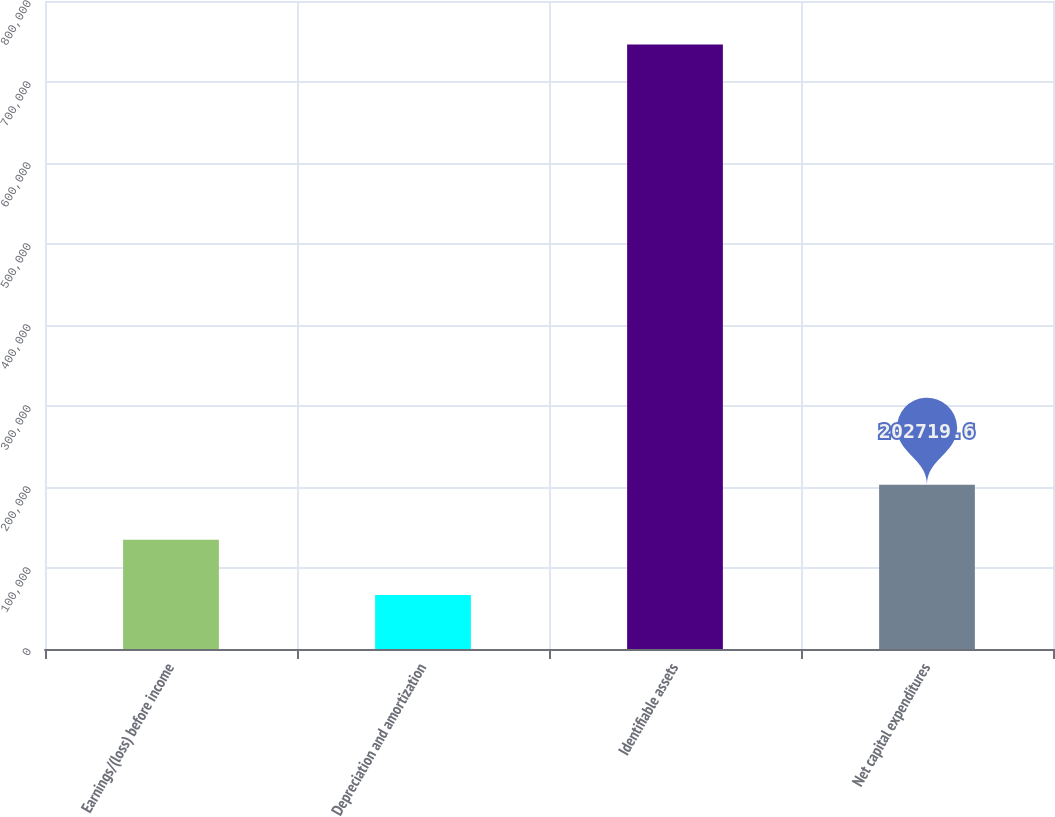Convert chart. <chart><loc_0><loc_0><loc_500><loc_500><bar_chart><fcel>Earnings/(loss) before income<fcel>Depreciation and amortization<fcel>Identifiable assets<fcel>Net capital expenditures<nl><fcel>134760<fcel>66800<fcel>746398<fcel>202720<nl></chart> 